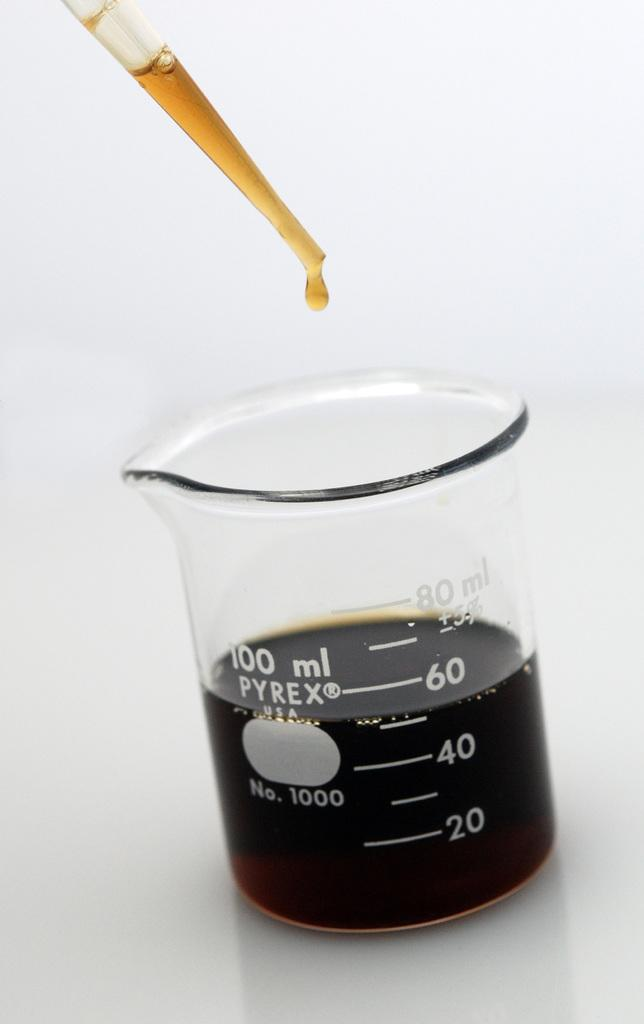<image>
Offer a succinct explanation of the picture presented. Pyrex measuring cup with up to 100 ml and number one thousand. 